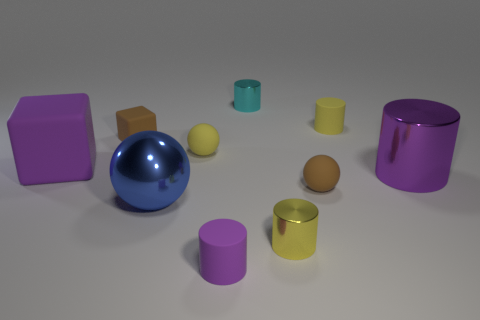Subtract all cyan cylinders. How many cylinders are left? 4 Subtract 2 cylinders. How many cylinders are left? 3 Subtract all blue cylinders. Subtract all purple blocks. How many cylinders are left? 5 Subtract all spheres. How many objects are left? 7 Subtract 0 red spheres. How many objects are left? 10 Subtract all tiny green metallic things. Subtract all big metal things. How many objects are left? 8 Add 1 big rubber things. How many big rubber things are left? 2 Add 6 brown matte things. How many brown matte things exist? 8 